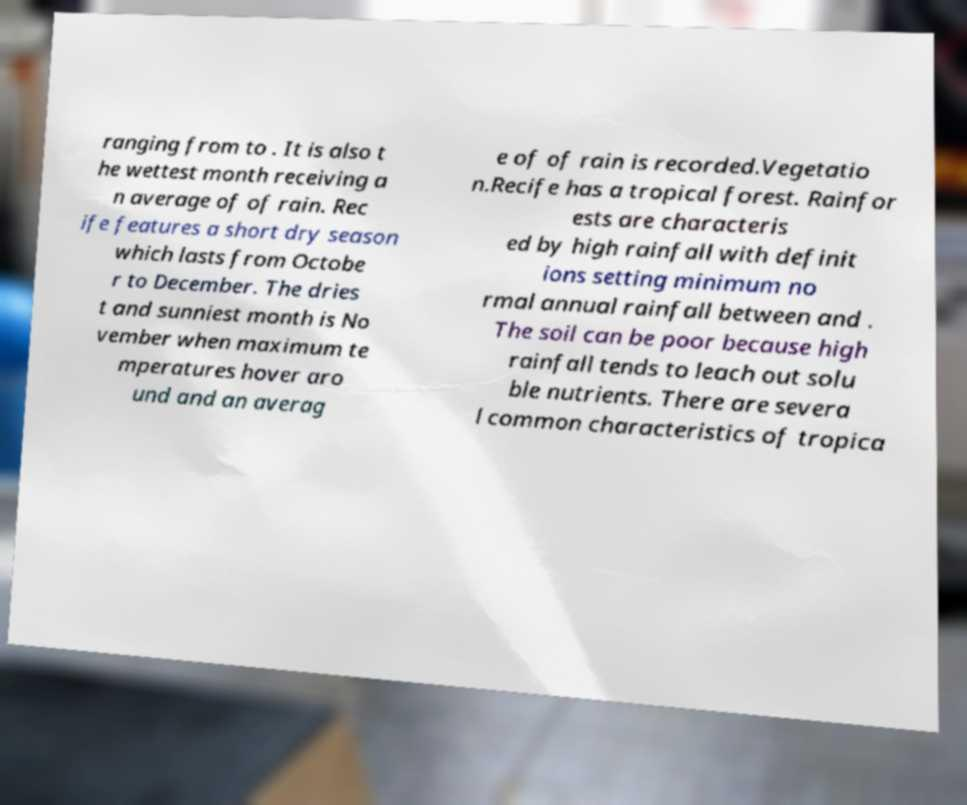Can you accurately transcribe the text from the provided image for me? ranging from to . It is also t he wettest month receiving a n average of of rain. Rec ife features a short dry season which lasts from Octobe r to December. The dries t and sunniest month is No vember when maximum te mperatures hover aro und and an averag e of of rain is recorded.Vegetatio n.Recife has a tropical forest. Rainfor ests are characteris ed by high rainfall with definit ions setting minimum no rmal annual rainfall between and . The soil can be poor because high rainfall tends to leach out solu ble nutrients. There are severa l common characteristics of tropica 